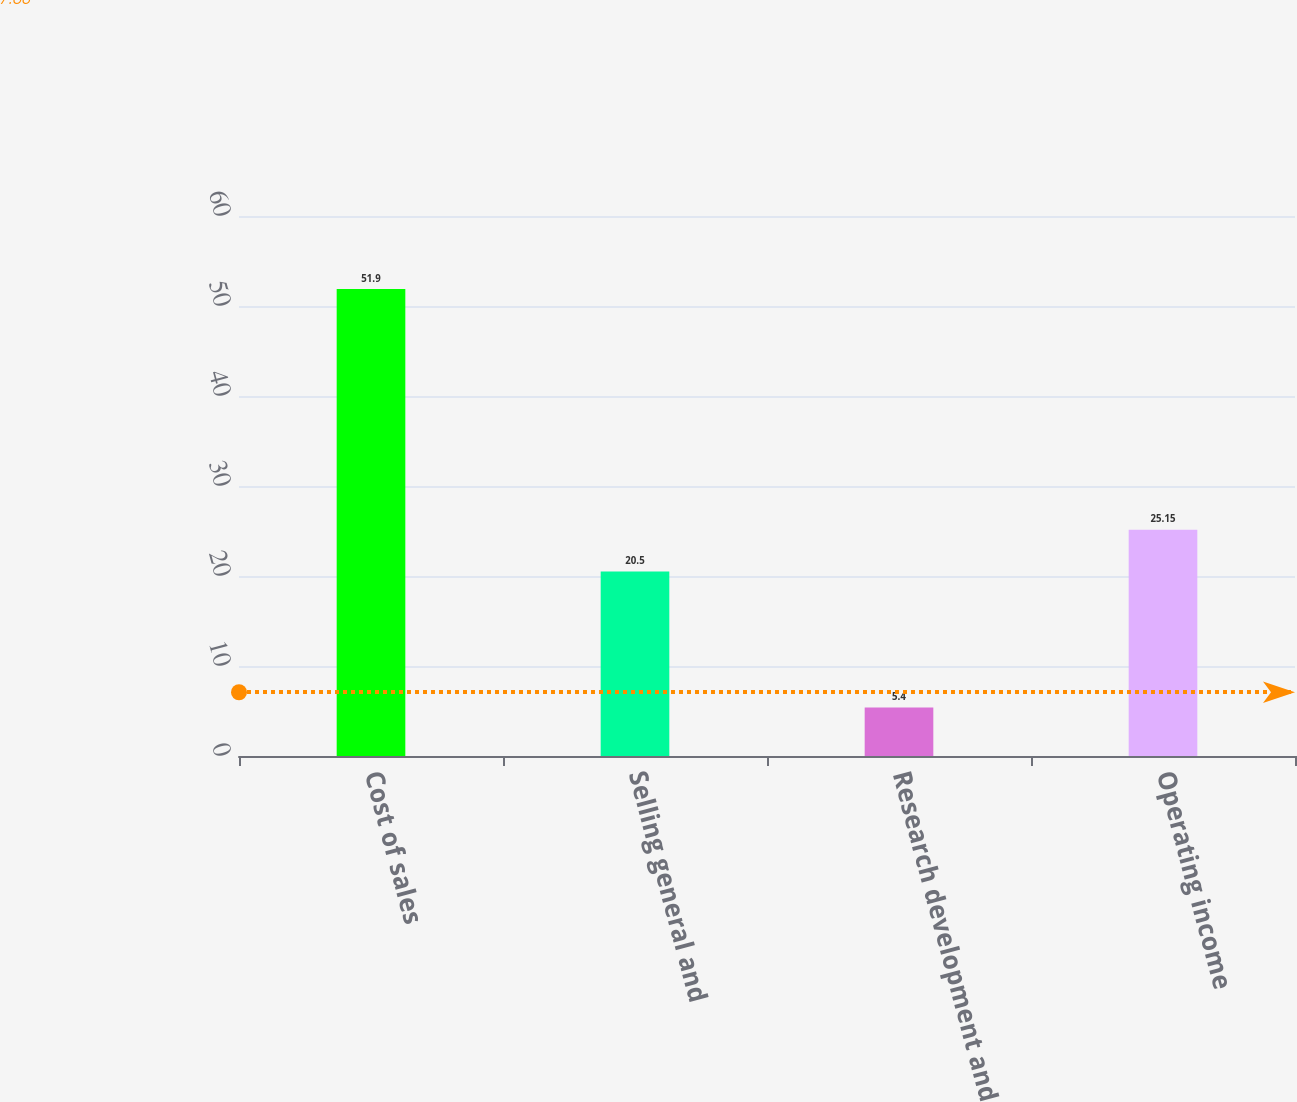Convert chart to OTSL. <chart><loc_0><loc_0><loc_500><loc_500><bar_chart><fcel>Cost of sales<fcel>Selling general and<fcel>Research development and<fcel>Operating income<nl><fcel>51.9<fcel>20.5<fcel>5.4<fcel>25.15<nl></chart> 